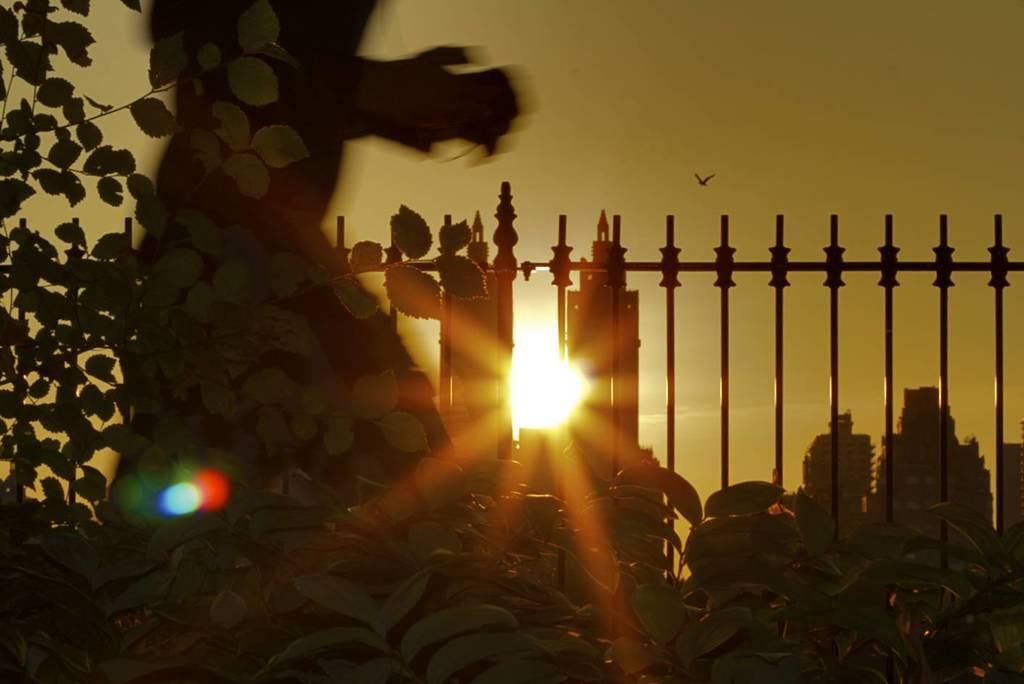In one or two sentences, can you explain what this image depicts? In this image, I can see the plants, iron grilles, buildings and a person. In the background, there is a bird flying in the sky. 